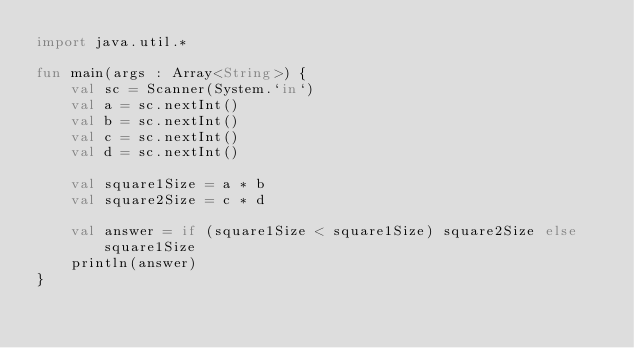Convert code to text. <code><loc_0><loc_0><loc_500><loc_500><_Kotlin_>import java.util.*

fun main(args : Array<String>) {
    val sc = Scanner(System.`in`)
    val a = sc.nextInt()
    val b = sc.nextInt()
    val c = sc.nextInt()
    val d = sc.nextInt()

    val square1Size = a * b
    val square2Size = c * d

    val answer = if (square1Size < square1Size) square2Size else square1Size
    println(answer)
}</code> 